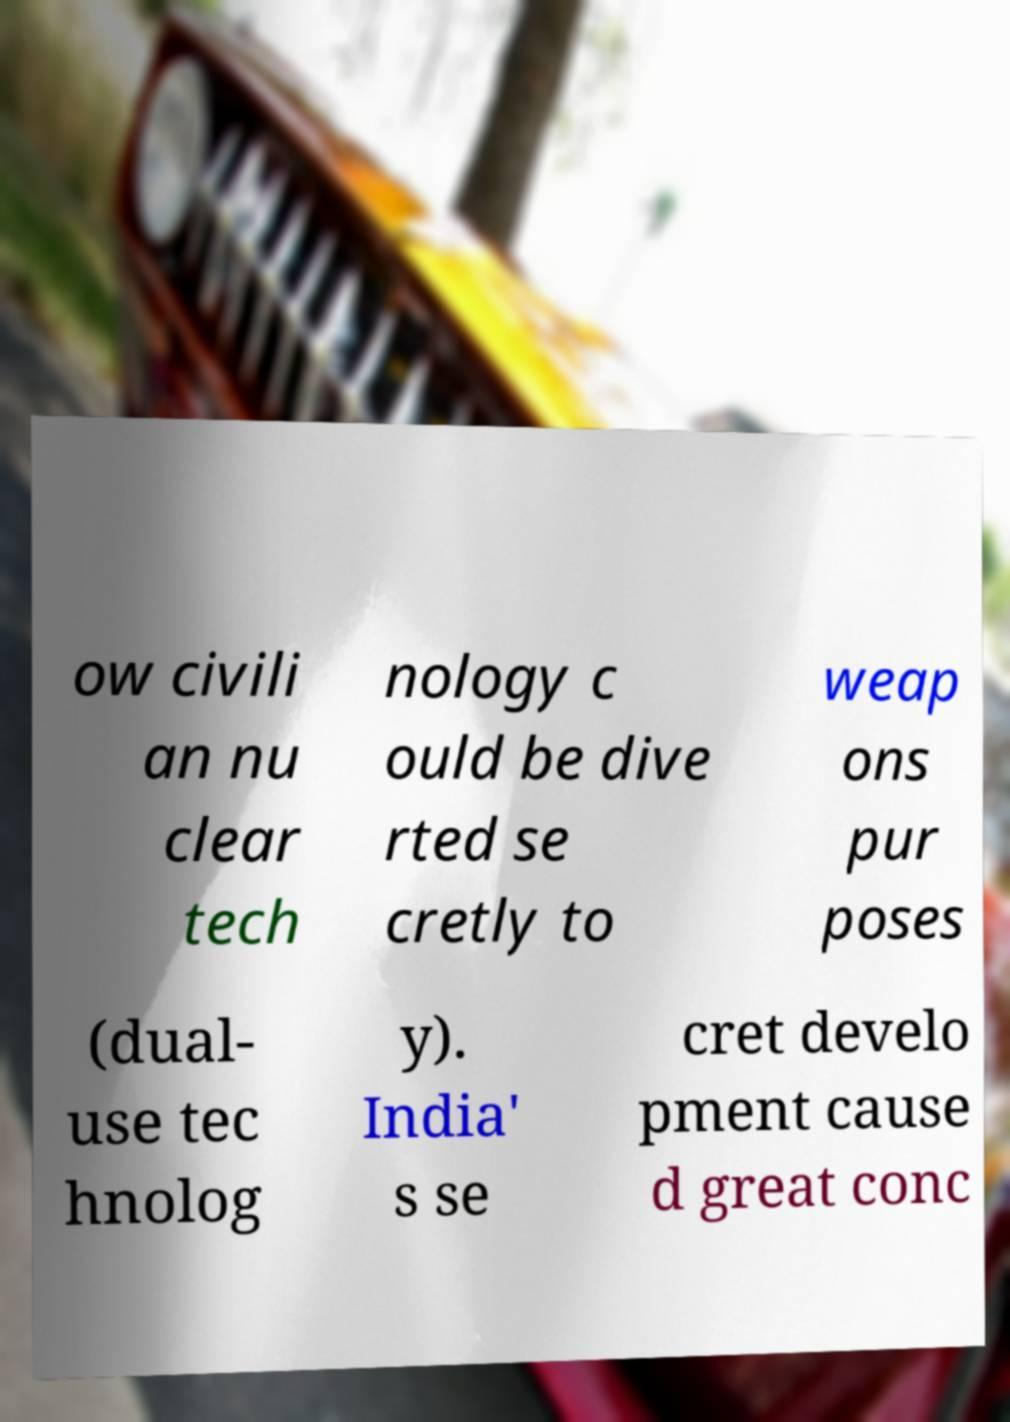Could you extract and type out the text from this image? ow civili an nu clear tech nology c ould be dive rted se cretly to weap ons pur poses (dual- use tec hnolog y). India' s se cret develo pment cause d great conc 